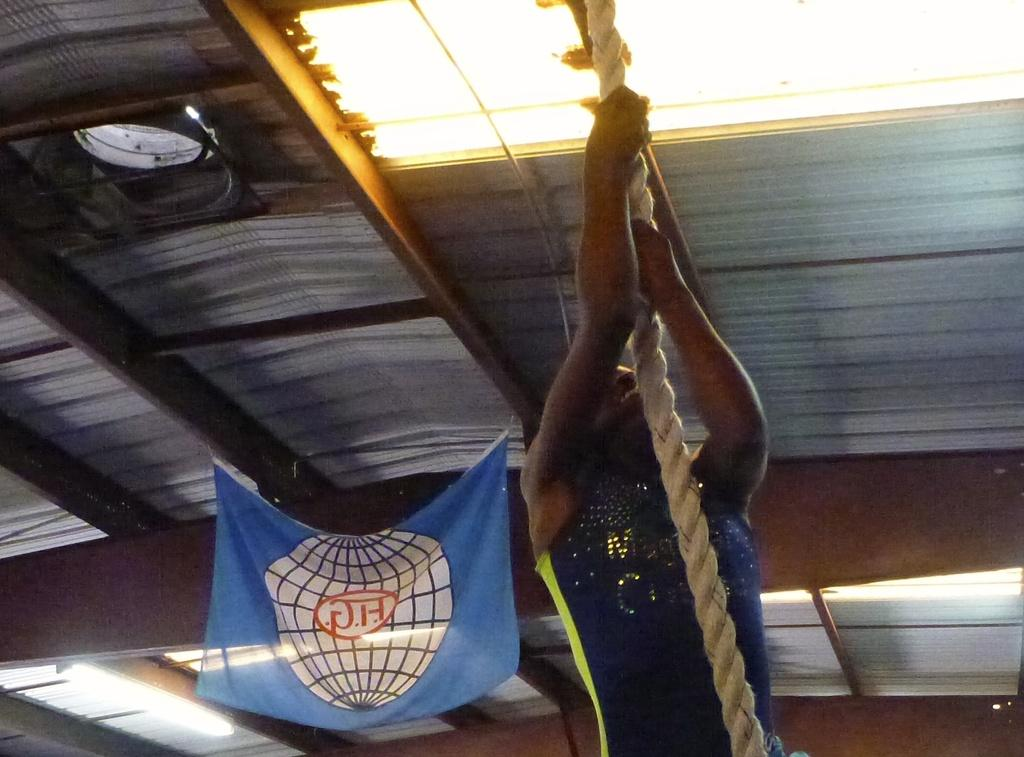What is the person in the image doing? The person is holding the roof in the image. What can be seen at the top of the image? There are lights at the top of the image. What is the main structure in the image? There is a roof in the image. What is attached to the roof? There is a banner on the roof in the image. What type of farmer is talking to the person holding the roof in the image? There is no farmer present in the image, nor is there anyone talking to the person holding the roof. 